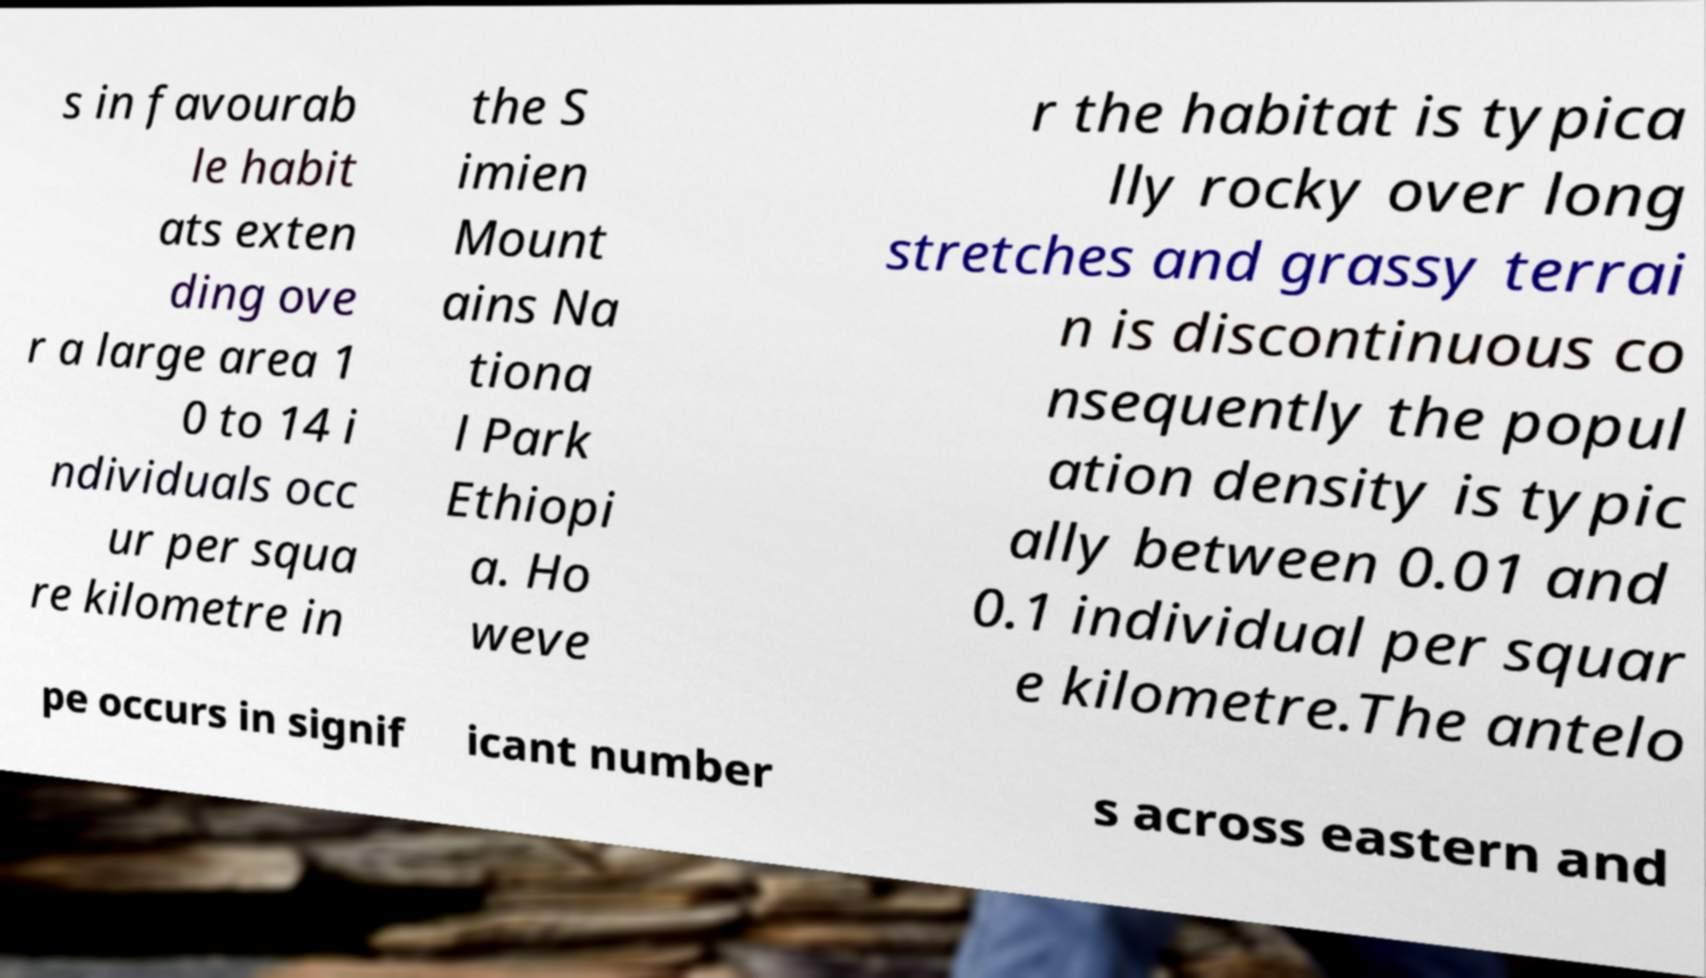There's text embedded in this image that I need extracted. Can you transcribe it verbatim? s in favourab le habit ats exten ding ove r a large area 1 0 to 14 i ndividuals occ ur per squa re kilometre in the S imien Mount ains Na tiona l Park Ethiopi a. Ho weve r the habitat is typica lly rocky over long stretches and grassy terrai n is discontinuous co nsequently the popul ation density is typic ally between 0.01 and 0.1 individual per squar e kilometre.The antelo pe occurs in signif icant number s across eastern and 